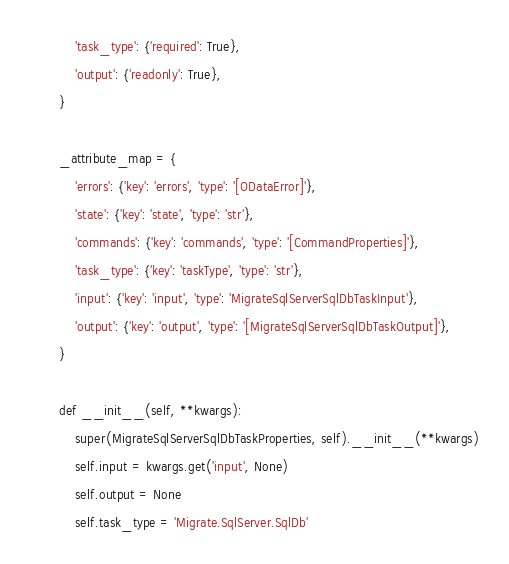Convert code to text. <code><loc_0><loc_0><loc_500><loc_500><_Python_>        'task_type': {'required': True},
        'output': {'readonly': True},
    }

    _attribute_map = {
        'errors': {'key': 'errors', 'type': '[ODataError]'},
        'state': {'key': 'state', 'type': 'str'},
        'commands': {'key': 'commands', 'type': '[CommandProperties]'},
        'task_type': {'key': 'taskType', 'type': 'str'},
        'input': {'key': 'input', 'type': 'MigrateSqlServerSqlDbTaskInput'},
        'output': {'key': 'output', 'type': '[MigrateSqlServerSqlDbTaskOutput]'},
    }

    def __init__(self, **kwargs):
        super(MigrateSqlServerSqlDbTaskProperties, self).__init__(**kwargs)
        self.input = kwargs.get('input', None)
        self.output = None
        self.task_type = 'Migrate.SqlServer.SqlDb'
</code> 